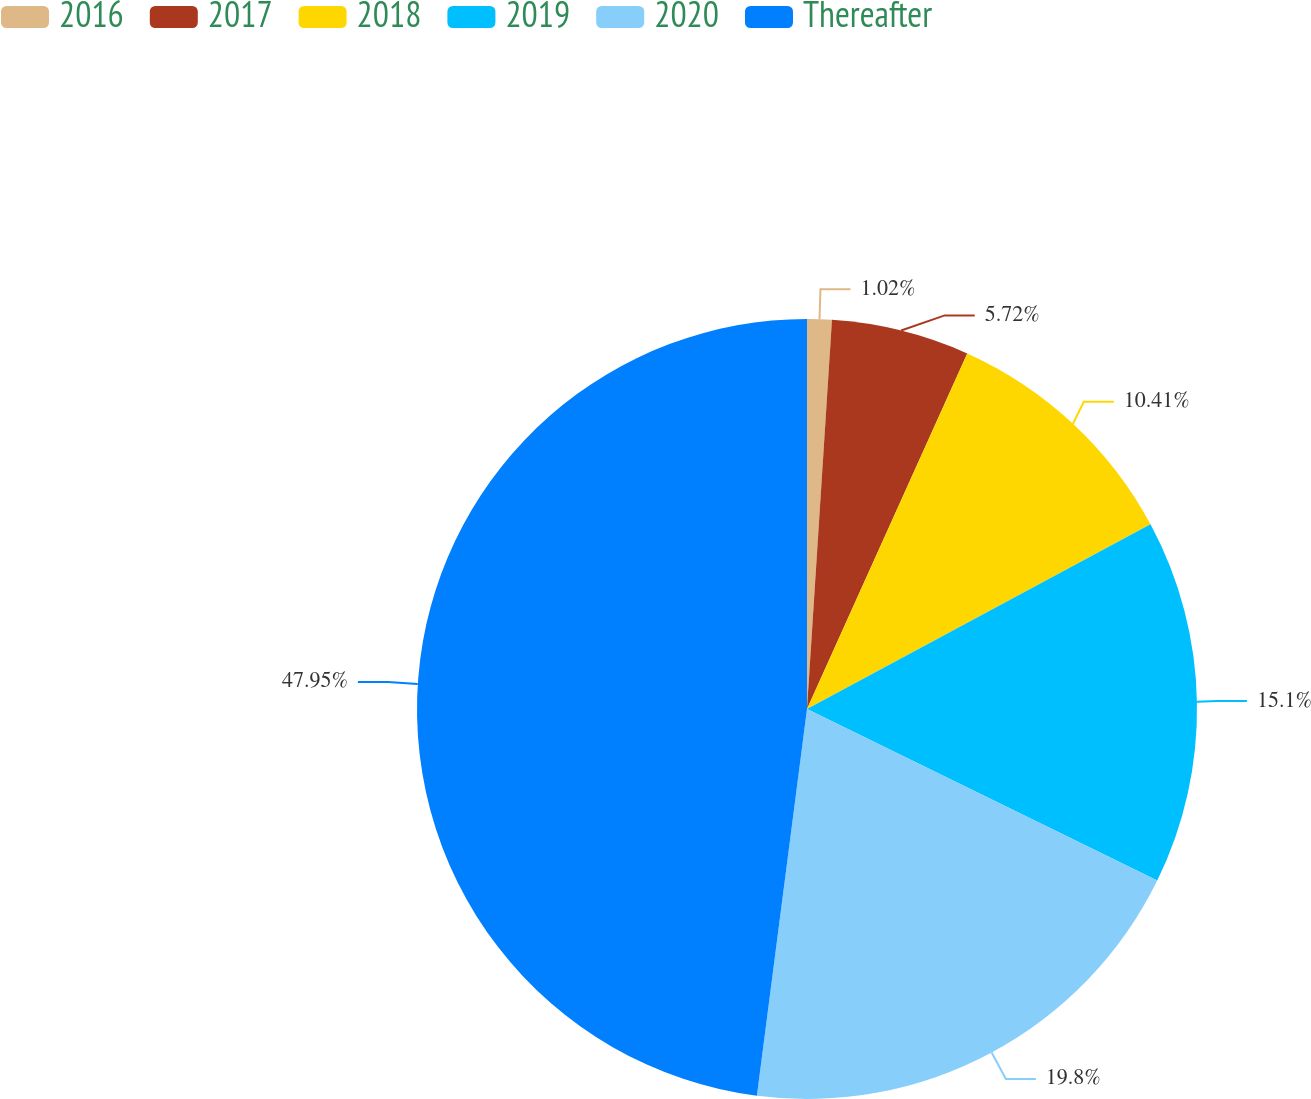<chart> <loc_0><loc_0><loc_500><loc_500><pie_chart><fcel>2016<fcel>2017<fcel>2018<fcel>2019<fcel>2020<fcel>Thereafter<nl><fcel>1.02%<fcel>5.72%<fcel>10.41%<fcel>15.1%<fcel>19.8%<fcel>47.95%<nl></chart> 